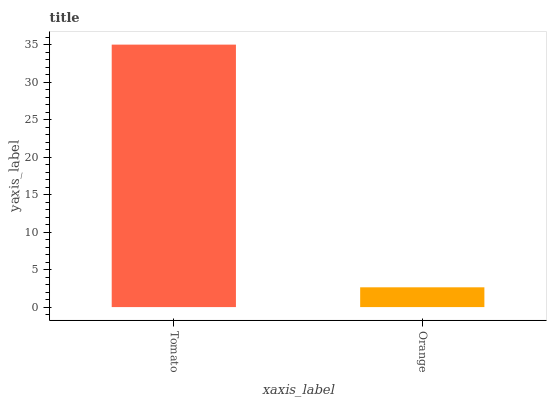Is Orange the maximum?
Answer yes or no. No. Is Tomato greater than Orange?
Answer yes or no. Yes. Is Orange less than Tomato?
Answer yes or no. Yes. Is Orange greater than Tomato?
Answer yes or no. No. Is Tomato less than Orange?
Answer yes or no. No. Is Tomato the high median?
Answer yes or no. Yes. Is Orange the low median?
Answer yes or no. Yes. Is Orange the high median?
Answer yes or no. No. Is Tomato the low median?
Answer yes or no. No. 